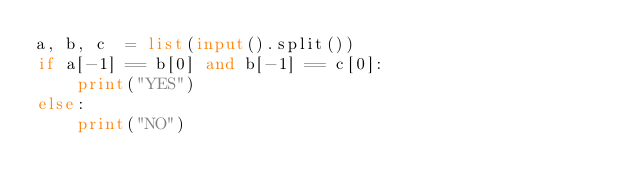<code> <loc_0><loc_0><loc_500><loc_500><_Python_>a, b, c  = list(input().split())
if a[-1] == b[0] and b[-1] == c[0]:
    print("YES")
else:
    print("NO")</code> 